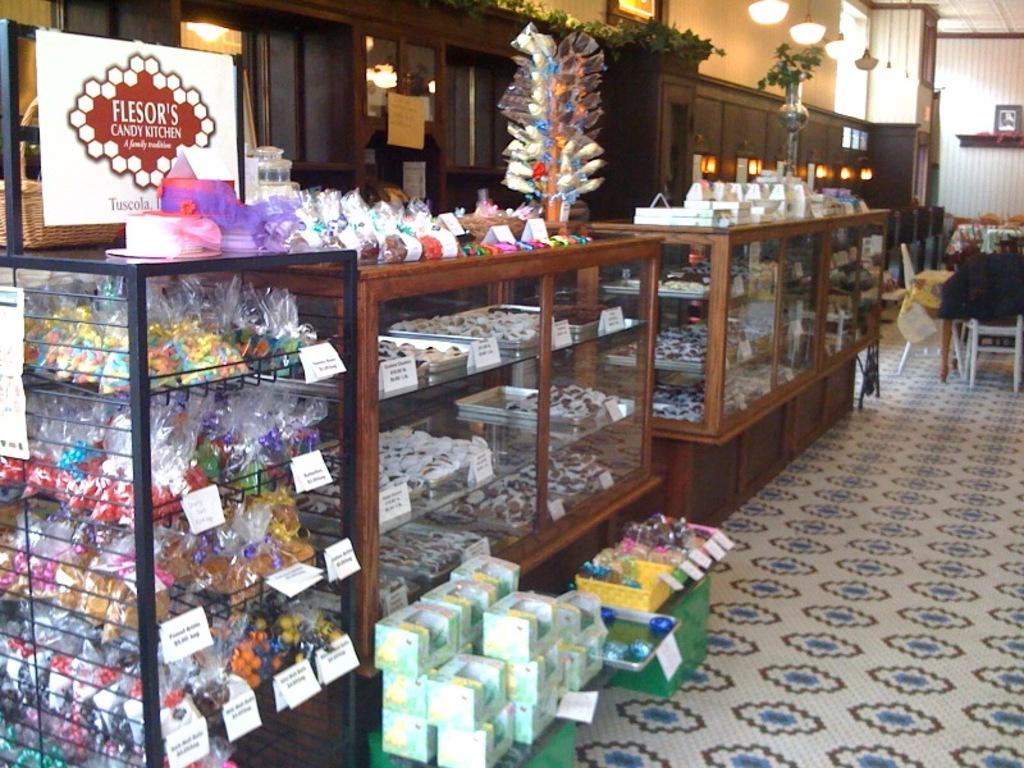What is the name of the shop?
Offer a terse response. Flesor's candy kitchen. 